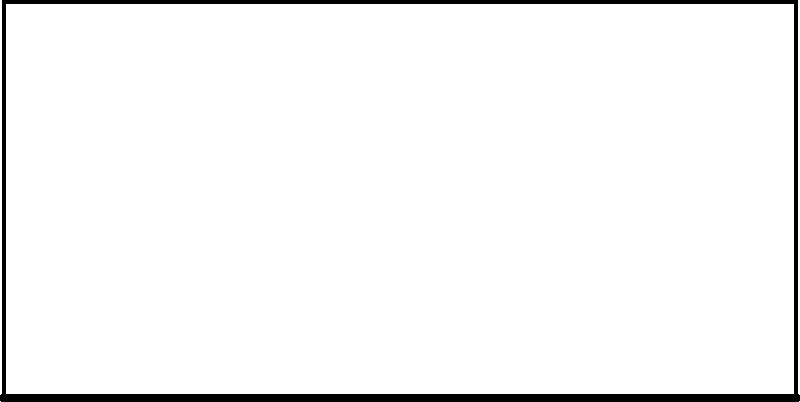Consider the suspension bridge diagram above, where wind load is represented by blue arrows. Based on the graph showing wind load distribution from point A to B, which mathematical function best describes the wind load pattern across the bridge span? To determine the mathematical function that best describes the wind load pattern, let's analyze the graph and the bridge structure step-by-step:

1. Observe the graph: The red curve shows an increasing trend from left to right, with a steeper increase towards the right side.

2. Consider the bridge structure: Suspension bridges typically have higher elevations at the towers and lower elevations at the center.

3. Wind behavior: Wind speed generally increases with height, following a logarithmic or power law profile.

4. Combining these factors: The wind load would be lower at the center of the bridge (lower height) and higher near the towers (greater height).

5. Mathematical functions:
   - Linear function: $f(x) = ax + b$
   - Quadratic function: $f(x) = ax^2 + bx + c$
   - Exponential function: $f(x) = ae^{bx}$

6. Analyzing the curve: The graph shows a gradually increasing slope, which is characteristic of an exponential function.

7. Exponential function properties: 
   - Always positive for positive $a$
   - Starts slowly and increases more rapidly
   - Never decreases

8. Conclusion: The exponential function $f(x) = ae^{bx}$ best matches the observed wind load distribution, where $x$ represents the distance along the bridge span, and $a$ and $b$ are constants determining the scale and growth rate of the wind load.
Answer: Exponential function: $f(x) = ae^{bx}$ 